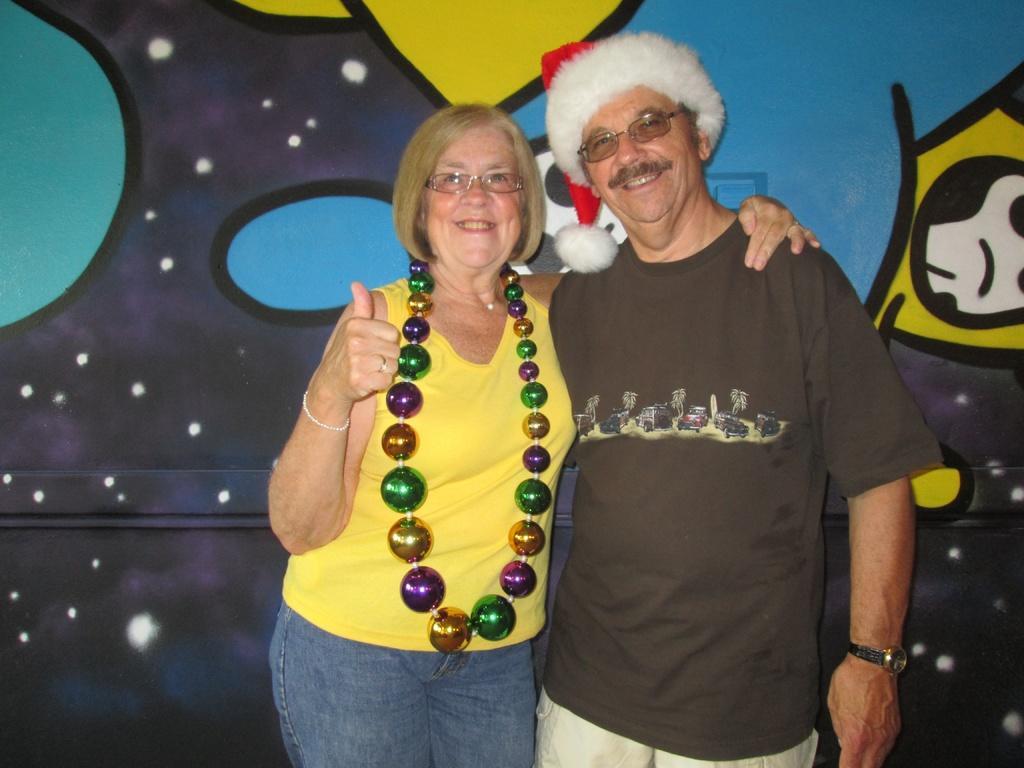Could you give a brief overview of what you see in this image? In this picture we can see a woman with the garland balls and a person with a cap. Behind the people there is a wall. 